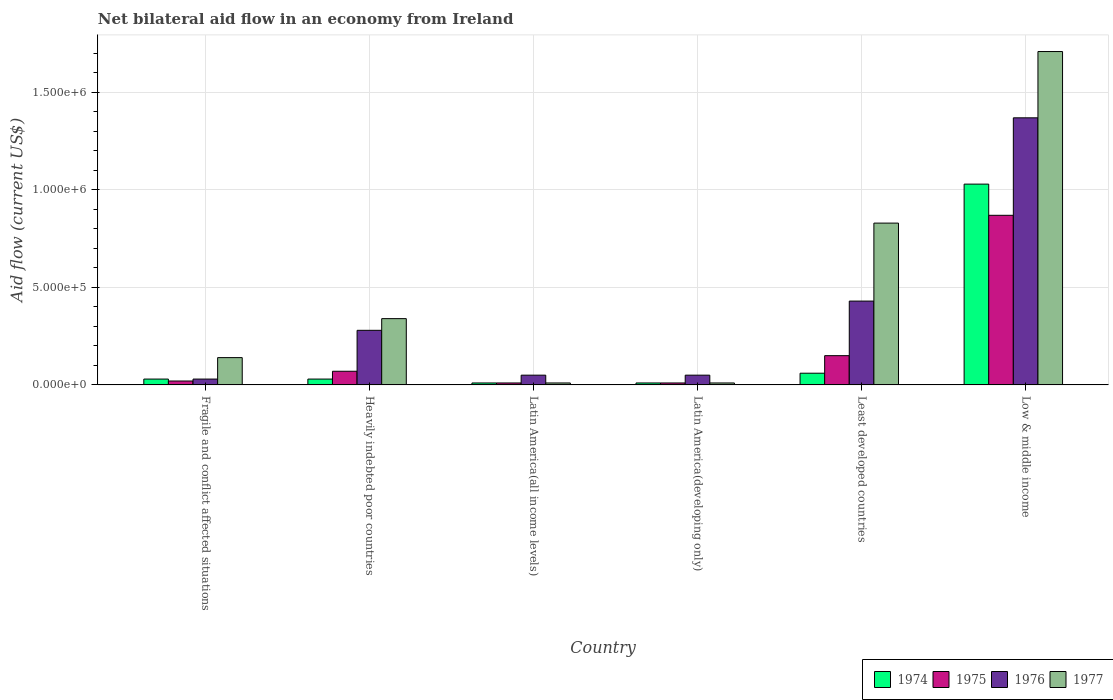How many different coloured bars are there?
Keep it short and to the point. 4. How many groups of bars are there?
Give a very brief answer. 6. Are the number of bars on each tick of the X-axis equal?
Provide a succinct answer. Yes. How many bars are there on the 1st tick from the left?
Make the answer very short. 4. How many bars are there on the 1st tick from the right?
Ensure brevity in your answer.  4. What is the label of the 6th group of bars from the left?
Give a very brief answer. Low & middle income. What is the net bilateral aid flow in 1977 in Latin America(developing only)?
Provide a succinct answer. 10000. Across all countries, what is the maximum net bilateral aid flow in 1977?
Your answer should be compact. 1.71e+06. In which country was the net bilateral aid flow in 1977 maximum?
Your response must be concise. Low & middle income. In which country was the net bilateral aid flow in 1975 minimum?
Offer a terse response. Latin America(all income levels). What is the total net bilateral aid flow in 1974 in the graph?
Offer a terse response. 1.17e+06. What is the difference between the net bilateral aid flow in 1977 in Latin America(all income levels) and that in Low & middle income?
Offer a very short reply. -1.70e+06. What is the difference between the net bilateral aid flow in 1977 in Low & middle income and the net bilateral aid flow in 1974 in Least developed countries?
Provide a succinct answer. 1.65e+06. What is the average net bilateral aid flow in 1976 per country?
Provide a succinct answer. 3.68e+05. What is the ratio of the net bilateral aid flow in 1974 in Latin America(all income levels) to that in Low & middle income?
Provide a succinct answer. 0.01. What is the difference between the highest and the lowest net bilateral aid flow in 1974?
Offer a terse response. 1.02e+06. Is it the case that in every country, the sum of the net bilateral aid flow in 1975 and net bilateral aid flow in 1977 is greater than the sum of net bilateral aid flow in 1976 and net bilateral aid flow in 1974?
Provide a short and direct response. No. What does the 2nd bar from the right in Low & middle income represents?
Provide a succinct answer. 1976. How many bars are there?
Provide a short and direct response. 24. Are all the bars in the graph horizontal?
Your answer should be very brief. No. How many countries are there in the graph?
Provide a succinct answer. 6. What is the difference between two consecutive major ticks on the Y-axis?
Your response must be concise. 5.00e+05. Does the graph contain grids?
Your response must be concise. Yes. How many legend labels are there?
Offer a terse response. 4. What is the title of the graph?
Provide a succinct answer. Net bilateral aid flow in an economy from Ireland. Does "1981" appear as one of the legend labels in the graph?
Ensure brevity in your answer.  No. What is the label or title of the X-axis?
Offer a terse response. Country. What is the label or title of the Y-axis?
Your response must be concise. Aid flow (current US$). What is the Aid flow (current US$) of 1975 in Fragile and conflict affected situations?
Your answer should be compact. 2.00e+04. What is the Aid flow (current US$) of 1977 in Fragile and conflict affected situations?
Ensure brevity in your answer.  1.40e+05. What is the Aid flow (current US$) in 1975 in Heavily indebted poor countries?
Offer a very short reply. 7.00e+04. What is the Aid flow (current US$) of 1976 in Heavily indebted poor countries?
Your answer should be compact. 2.80e+05. What is the Aid flow (current US$) of 1974 in Latin America(all income levels)?
Keep it short and to the point. 10000. What is the Aid flow (current US$) in 1976 in Latin America(all income levels)?
Your answer should be compact. 5.00e+04. What is the Aid flow (current US$) in 1977 in Latin America(all income levels)?
Your answer should be compact. 10000. What is the Aid flow (current US$) of 1974 in Least developed countries?
Your answer should be compact. 6.00e+04. What is the Aid flow (current US$) of 1976 in Least developed countries?
Offer a very short reply. 4.30e+05. What is the Aid flow (current US$) in 1977 in Least developed countries?
Offer a terse response. 8.30e+05. What is the Aid flow (current US$) of 1974 in Low & middle income?
Your answer should be compact. 1.03e+06. What is the Aid flow (current US$) of 1975 in Low & middle income?
Give a very brief answer. 8.70e+05. What is the Aid flow (current US$) of 1976 in Low & middle income?
Make the answer very short. 1.37e+06. What is the Aid flow (current US$) in 1977 in Low & middle income?
Your answer should be very brief. 1.71e+06. Across all countries, what is the maximum Aid flow (current US$) of 1974?
Make the answer very short. 1.03e+06. Across all countries, what is the maximum Aid flow (current US$) of 1975?
Provide a short and direct response. 8.70e+05. Across all countries, what is the maximum Aid flow (current US$) in 1976?
Your response must be concise. 1.37e+06. Across all countries, what is the maximum Aid flow (current US$) in 1977?
Ensure brevity in your answer.  1.71e+06. Across all countries, what is the minimum Aid flow (current US$) of 1974?
Offer a terse response. 10000. What is the total Aid flow (current US$) in 1974 in the graph?
Keep it short and to the point. 1.17e+06. What is the total Aid flow (current US$) of 1975 in the graph?
Offer a terse response. 1.13e+06. What is the total Aid flow (current US$) of 1976 in the graph?
Provide a succinct answer. 2.21e+06. What is the total Aid flow (current US$) in 1977 in the graph?
Offer a very short reply. 3.04e+06. What is the difference between the Aid flow (current US$) of 1977 in Fragile and conflict affected situations and that in Heavily indebted poor countries?
Ensure brevity in your answer.  -2.00e+05. What is the difference between the Aid flow (current US$) in 1974 in Fragile and conflict affected situations and that in Latin America(developing only)?
Make the answer very short. 2.00e+04. What is the difference between the Aid flow (current US$) of 1976 in Fragile and conflict affected situations and that in Latin America(developing only)?
Your answer should be very brief. -2.00e+04. What is the difference between the Aid flow (current US$) in 1977 in Fragile and conflict affected situations and that in Latin America(developing only)?
Your answer should be very brief. 1.30e+05. What is the difference between the Aid flow (current US$) of 1975 in Fragile and conflict affected situations and that in Least developed countries?
Ensure brevity in your answer.  -1.30e+05. What is the difference between the Aid flow (current US$) of 1976 in Fragile and conflict affected situations and that in Least developed countries?
Your answer should be very brief. -4.00e+05. What is the difference between the Aid flow (current US$) of 1977 in Fragile and conflict affected situations and that in Least developed countries?
Make the answer very short. -6.90e+05. What is the difference between the Aid flow (current US$) of 1974 in Fragile and conflict affected situations and that in Low & middle income?
Offer a terse response. -1.00e+06. What is the difference between the Aid flow (current US$) of 1975 in Fragile and conflict affected situations and that in Low & middle income?
Keep it short and to the point. -8.50e+05. What is the difference between the Aid flow (current US$) in 1976 in Fragile and conflict affected situations and that in Low & middle income?
Give a very brief answer. -1.34e+06. What is the difference between the Aid flow (current US$) in 1977 in Fragile and conflict affected situations and that in Low & middle income?
Keep it short and to the point. -1.57e+06. What is the difference between the Aid flow (current US$) in 1974 in Heavily indebted poor countries and that in Latin America(all income levels)?
Ensure brevity in your answer.  2.00e+04. What is the difference between the Aid flow (current US$) of 1977 in Heavily indebted poor countries and that in Latin America(all income levels)?
Provide a short and direct response. 3.30e+05. What is the difference between the Aid flow (current US$) of 1974 in Heavily indebted poor countries and that in Latin America(developing only)?
Keep it short and to the point. 2.00e+04. What is the difference between the Aid flow (current US$) of 1975 in Heavily indebted poor countries and that in Latin America(developing only)?
Keep it short and to the point. 6.00e+04. What is the difference between the Aid flow (current US$) in 1976 in Heavily indebted poor countries and that in Latin America(developing only)?
Make the answer very short. 2.30e+05. What is the difference between the Aid flow (current US$) in 1977 in Heavily indebted poor countries and that in Least developed countries?
Your answer should be compact. -4.90e+05. What is the difference between the Aid flow (current US$) of 1975 in Heavily indebted poor countries and that in Low & middle income?
Offer a very short reply. -8.00e+05. What is the difference between the Aid flow (current US$) in 1976 in Heavily indebted poor countries and that in Low & middle income?
Your answer should be compact. -1.09e+06. What is the difference between the Aid flow (current US$) of 1977 in Heavily indebted poor countries and that in Low & middle income?
Offer a very short reply. -1.37e+06. What is the difference between the Aid flow (current US$) in 1974 in Latin America(all income levels) and that in Latin America(developing only)?
Your answer should be compact. 0. What is the difference between the Aid flow (current US$) of 1976 in Latin America(all income levels) and that in Latin America(developing only)?
Your answer should be compact. 0. What is the difference between the Aid flow (current US$) in 1977 in Latin America(all income levels) and that in Latin America(developing only)?
Provide a short and direct response. 0. What is the difference between the Aid flow (current US$) of 1976 in Latin America(all income levels) and that in Least developed countries?
Offer a terse response. -3.80e+05. What is the difference between the Aid flow (current US$) of 1977 in Latin America(all income levels) and that in Least developed countries?
Your response must be concise. -8.20e+05. What is the difference between the Aid flow (current US$) of 1974 in Latin America(all income levels) and that in Low & middle income?
Provide a short and direct response. -1.02e+06. What is the difference between the Aid flow (current US$) of 1975 in Latin America(all income levels) and that in Low & middle income?
Your answer should be compact. -8.60e+05. What is the difference between the Aid flow (current US$) of 1976 in Latin America(all income levels) and that in Low & middle income?
Make the answer very short. -1.32e+06. What is the difference between the Aid flow (current US$) of 1977 in Latin America(all income levels) and that in Low & middle income?
Keep it short and to the point. -1.70e+06. What is the difference between the Aid flow (current US$) of 1974 in Latin America(developing only) and that in Least developed countries?
Offer a very short reply. -5.00e+04. What is the difference between the Aid flow (current US$) in 1976 in Latin America(developing only) and that in Least developed countries?
Your response must be concise. -3.80e+05. What is the difference between the Aid flow (current US$) of 1977 in Latin America(developing only) and that in Least developed countries?
Offer a very short reply. -8.20e+05. What is the difference between the Aid flow (current US$) in 1974 in Latin America(developing only) and that in Low & middle income?
Provide a succinct answer. -1.02e+06. What is the difference between the Aid flow (current US$) in 1975 in Latin America(developing only) and that in Low & middle income?
Give a very brief answer. -8.60e+05. What is the difference between the Aid flow (current US$) of 1976 in Latin America(developing only) and that in Low & middle income?
Your response must be concise. -1.32e+06. What is the difference between the Aid flow (current US$) of 1977 in Latin America(developing only) and that in Low & middle income?
Offer a very short reply. -1.70e+06. What is the difference between the Aid flow (current US$) of 1974 in Least developed countries and that in Low & middle income?
Offer a very short reply. -9.70e+05. What is the difference between the Aid flow (current US$) in 1975 in Least developed countries and that in Low & middle income?
Ensure brevity in your answer.  -7.20e+05. What is the difference between the Aid flow (current US$) of 1976 in Least developed countries and that in Low & middle income?
Offer a terse response. -9.40e+05. What is the difference between the Aid flow (current US$) in 1977 in Least developed countries and that in Low & middle income?
Your answer should be very brief. -8.80e+05. What is the difference between the Aid flow (current US$) in 1974 in Fragile and conflict affected situations and the Aid flow (current US$) in 1975 in Heavily indebted poor countries?
Your answer should be very brief. -4.00e+04. What is the difference between the Aid flow (current US$) in 1974 in Fragile and conflict affected situations and the Aid flow (current US$) in 1977 in Heavily indebted poor countries?
Keep it short and to the point. -3.10e+05. What is the difference between the Aid flow (current US$) in 1975 in Fragile and conflict affected situations and the Aid flow (current US$) in 1977 in Heavily indebted poor countries?
Your answer should be compact. -3.20e+05. What is the difference between the Aid flow (current US$) of 1976 in Fragile and conflict affected situations and the Aid flow (current US$) of 1977 in Heavily indebted poor countries?
Your answer should be compact. -3.10e+05. What is the difference between the Aid flow (current US$) of 1974 in Fragile and conflict affected situations and the Aid flow (current US$) of 1975 in Latin America(all income levels)?
Make the answer very short. 2.00e+04. What is the difference between the Aid flow (current US$) of 1975 in Fragile and conflict affected situations and the Aid flow (current US$) of 1977 in Latin America(developing only)?
Provide a short and direct response. 10000. What is the difference between the Aid flow (current US$) of 1976 in Fragile and conflict affected situations and the Aid flow (current US$) of 1977 in Latin America(developing only)?
Offer a terse response. 2.00e+04. What is the difference between the Aid flow (current US$) in 1974 in Fragile and conflict affected situations and the Aid flow (current US$) in 1976 in Least developed countries?
Offer a very short reply. -4.00e+05. What is the difference between the Aid flow (current US$) of 1974 in Fragile and conflict affected situations and the Aid flow (current US$) of 1977 in Least developed countries?
Your response must be concise. -8.00e+05. What is the difference between the Aid flow (current US$) of 1975 in Fragile and conflict affected situations and the Aid flow (current US$) of 1976 in Least developed countries?
Provide a succinct answer. -4.10e+05. What is the difference between the Aid flow (current US$) of 1975 in Fragile and conflict affected situations and the Aid flow (current US$) of 1977 in Least developed countries?
Your answer should be compact. -8.10e+05. What is the difference between the Aid flow (current US$) in 1976 in Fragile and conflict affected situations and the Aid flow (current US$) in 1977 in Least developed countries?
Ensure brevity in your answer.  -8.00e+05. What is the difference between the Aid flow (current US$) in 1974 in Fragile and conflict affected situations and the Aid flow (current US$) in 1975 in Low & middle income?
Your response must be concise. -8.40e+05. What is the difference between the Aid flow (current US$) of 1974 in Fragile and conflict affected situations and the Aid flow (current US$) of 1976 in Low & middle income?
Make the answer very short. -1.34e+06. What is the difference between the Aid flow (current US$) in 1974 in Fragile and conflict affected situations and the Aid flow (current US$) in 1977 in Low & middle income?
Offer a very short reply. -1.68e+06. What is the difference between the Aid flow (current US$) of 1975 in Fragile and conflict affected situations and the Aid flow (current US$) of 1976 in Low & middle income?
Ensure brevity in your answer.  -1.35e+06. What is the difference between the Aid flow (current US$) in 1975 in Fragile and conflict affected situations and the Aid flow (current US$) in 1977 in Low & middle income?
Keep it short and to the point. -1.69e+06. What is the difference between the Aid flow (current US$) of 1976 in Fragile and conflict affected situations and the Aid flow (current US$) of 1977 in Low & middle income?
Give a very brief answer. -1.68e+06. What is the difference between the Aid flow (current US$) in 1974 in Heavily indebted poor countries and the Aid flow (current US$) in 1975 in Latin America(all income levels)?
Offer a terse response. 2.00e+04. What is the difference between the Aid flow (current US$) of 1975 in Heavily indebted poor countries and the Aid flow (current US$) of 1976 in Latin America(all income levels)?
Your answer should be compact. 2.00e+04. What is the difference between the Aid flow (current US$) in 1976 in Heavily indebted poor countries and the Aid flow (current US$) in 1977 in Latin America(all income levels)?
Keep it short and to the point. 2.70e+05. What is the difference between the Aid flow (current US$) of 1974 in Heavily indebted poor countries and the Aid flow (current US$) of 1975 in Latin America(developing only)?
Make the answer very short. 2.00e+04. What is the difference between the Aid flow (current US$) of 1974 in Heavily indebted poor countries and the Aid flow (current US$) of 1977 in Latin America(developing only)?
Offer a terse response. 2.00e+04. What is the difference between the Aid flow (current US$) of 1975 in Heavily indebted poor countries and the Aid flow (current US$) of 1976 in Latin America(developing only)?
Provide a short and direct response. 2.00e+04. What is the difference between the Aid flow (current US$) of 1975 in Heavily indebted poor countries and the Aid flow (current US$) of 1977 in Latin America(developing only)?
Offer a terse response. 6.00e+04. What is the difference between the Aid flow (current US$) in 1976 in Heavily indebted poor countries and the Aid flow (current US$) in 1977 in Latin America(developing only)?
Keep it short and to the point. 2.70e+05. What is the difference between the Aid flow (current US$) of 1974 in Heavily indebted poor countries and the Aid flow (current US$) of 1975 in Least developed countries?
Make the answer very short. -1.20e+05. What is the difference between the Aid flow (current US$) in 1974 in Heavily indebted poor countries and the Aid flow (current US$) in 1976 in Least developed countries?
Ensure brevity in your answer.  -4.00e+05. What is the difference between the Aid flow (current US$) in 1974 in Heavily indebted poor countries and the Aid flow (current US$) in 1977 in Least developed countries?
Provide a short and direct response. -8.00e+05. What is the difference between the Aid flow (current US$) in 1975 in Heavily indebted poor countries and the Aid flow (current US$) in 1976 in Least developed countries?
Your answer should be compact. -3.60e+05. What is the difference between the Aid flow (current US$) of 1975 in Heavily indebted poor countries and the Aid flow (current US$) of 1977 in Least developed countries?
Keep it short and to the point. -7.60e+05. What is the difference between the Aid flow (current US$) in 1976 in Heavily indebted poor countries and the Aid flow (current US$) in 1977 in Least developed countries?
Offer a very short reply. -5.50e+05. What is the difference between the Aid flow (current US$) in 1974 in Heavily indebted poor countries and the Aid flow (current US$) in 1975 in Low & middle income?
Give a very brief answer. -8.40e+05. What is the difference between the Aid flow (current US$) of 1974 in Heavily indebted poor countries and the Aid flow (current US$) of 1976 in Low & middle income?
Keep it short and to the point. -1.34e+06. What is the difference between the Aid flow (current US$) of 1974 in Heavily indebted poor countries and the Aid flow (current US$) of 1977 in Low & middle income?
Offer a very short reply. -1.68e+06. What is the difference between the Aid flow (current US$) of 1975 in Heavily indebted poor countries and the Aid flow (current US$) of 1976 in Low & middle income?
Your answer should be very brief. -1.30e+06. What is the difference between the Aid flow (current US$) of 1975 in Heavily indebted poor countries and the Aid flow (current US$) of 1977 in Low & middle income?
Your response must be concise. -1.64e+06. What is the difference between the Aid flow (current US$) in 1976 in Heavily indebted poor countries and the Aid flow (current US$) in 1977 in Low & middle income?
Provide a short and direct response. -1.43e+06. What is the difference between the Aid flow (current US$) in 1974 in Latin America(all income levels) and the Aid flow (current US$) in 1975 in Latin America(developing only)?
Provide a succinct answer. 0. What is the difference between the Aid flow (current US$) in 1975 in Latin America(all income levels) and the Aid flow (current US$) in 1976 in Latin America(developing only)?
Keep it short and to the point. -4.00e+04. What is the difference between the Aid flow (current US$) of 1976 in Latin America(all income levels) and the Aid flow (current US$) of 1977 in Latin America(developing only)?
Keep it short and to the point. 4.00e+04. What is the difference between the Aid flow (current US$) in 1974 in Latin America(all income levels) and the Aid flow (current US$) in 1975 in Least developed countries?
Your answer should be very brief. -1.40e+05. What is the difference between the Aid flow (current US$) in 1974 in Latin America(all income levels) and the Aid flow (current US$) in 1976 in Least developed countries?
Offer a very short reply. -4.20e+05. What is the difference between the Aid flow (current US$) of 1974 in Latin America(all income levels) and the Aid flow (current US$) of 1977 in Least developed countries?
Provide a short and direct response. -8.20e+05. What is the difference between the Aid flow (current US$) in 1975 in Latin America(all income levels) and the Aid flow (current US$) in 1976 in Least developed countries?
Give a very brief answer. -4.20e+05. What is the difference between the Aid flow (current US$) in 1975 in Latin America(all income levels) and the Aid flow (current US$) in 1977 in Least developed countries?
Your answer should be compact. -8.20e+05. What is the difference between the Aid flow (current US$) in 1976 in Latin America(all income levels) and the Aid flow (current US$) in 1977 in Least developed countries?
Your answer should be compact. -7.80e+05. What is the difference between the Aid flow (current US$) in 1974 in Latin America(all income levels) and the Aid flow (current US$) in 1975 in Low & middle income?
Offer a terse response. -8.60e+05. What is the difference between the Aid flow (current US$) in 1974 in Latin America(all income levels) and the Aid flow (current US$) in 1976 in Low & middle income?
Offer a terse response. -1.36e+06. What is the difference between the Aid flow (current US$) of 1974 in Latin America(all income levels) and the Aid flow (current US$) of 1977 in Low & middle income?
Provide a succinct answer. -1.70e+06. What is the difference between the Aid flow (current US$) in 1975 in Latin America(all income levels) and the Aid flow (current US$) in 1976 in Low & middle income?
Your answer should be very brief. -1.36e+06. What is the difference between the Aid flow (current US$) in 1975 in Latin America(all income levels) and the Aid flow (current US$) in 1977 in Low & middle income?
Provide a short and direct response. -1.70e+06. What is the difference between the Aid flow (current US$) of 1976 in Latin America(all income levels) and the Aid flow (current US$) of 1977 in Low & middle income?
Keep it short and to the point. -1.66e+06. What is the difference between the Aid flow (current US$) of 1974 in Latin America(developing only) and the Aid flow (current US$) of 1975 in Least developed countries?
Offer a terse response. -1.40e+05. What is the difference between the Aid flow (current US$) of 1974 in Latin America(developing only) and the Aid flow (current US$) of 1976 in Least developed countries?
Provide a succinct answer. -4.20e+05. What is the difference between the Aid flow (current US$) in 1974 in Latin America(developing only) and the Aid flow (current US$) in 1977 in Least developed countries?
Ensure brevity in your answer.  -8.20e+05. What is the difference between the Aid flow (current US$) in 1975 in Latin America(developing only) and the Aid flow (current US$) in 1976 in Least developed countries?
Your response must be concise. -4.20e+05. What is the difference between the Aid flow (current US$) in 1975 in Latin America(developing only) and the Aid flow (current US$) in 1977 in Least developed countries?
Your answer should be very brief. -8.20e+05. What is the difference between the Aid flow (current US$) in 1976 in Latin America(developing only) and the Aid flow (current US$) in 1977 in Least developed countries?
Your answer should be very brief. -7.80e+05. What is the difference between the Aid flow (current US$) of 1974 in Latin America(developing only) and the Aid flow (current US$) of 1975 in Low & middle income?
Your response must be concise. -8.60e+05. What is the difference between the Aid flow (current US$) of 1974 in Latin America(developing only) and the Aid flow (current US$) of 1976 in Low & middle income?
Make the answer very short. -1.36e+06. What is the difference between the Aid flow (current US$) in 1974 in Latin America(developing only) and the Aid flow (current US$) in 1977 in Low & middle income?
Your answer should be compact. -1.70e+06. What is the difference between the Aid flow (current US$) in 1975 in Latin America(developing only) and the Aid flow (current US$) in 1976 in Low & middle income?
Provide a short and direct response. -1.36e+06. What is the difference between the Aid flow (current US$) in 1975 in Latin America(developing only) and the Aid flow (current US$) in 1977 in Low & middle income?
Make the answer very short. -1.70e+06. What is the difference between the Aid flow (current US$) of 1976 in Latin America(developing only) and the Aid flow (current US$) of 1977 in Low & middle income?
Offer a very short reply. -1.66e+06. What is the difference between the Aid flow (current US$) of 1974 in Least developed countries and the Aid flow (current US$) of 1975 in Low & middle income?
Your answer should be compact. -8.10e+05. What is the difference between the Aid flow (current US$) of 1974 in Least developed countries and the Aid flow (current US$) of 1976 in Low & middle income?
Your answer should be very brief. -1.31e+06. What is the difference between the Aid flow (current US$) of 1974 in Least developed countries and the Aid flow (current US$) of 1977 in Low & middle income?
Make the answer very short. -1.65e+06. What is the difference between the Aid flow (current US$) in 1975 in Least developed countries and the Aid flow (current US$) in 1976 in Low & middle income?
Keep it short and to the point. -1.22e+06. What is the difference between the Aid flow (current US$) of 1975 in Least developed countries and the Aid flow (current US$) of 1977 in Low & middle income?
Your response must be concise. -1.56e+06. What is the difference between the Aid flow (current US$) of 1976 in Least developed countries and the Aid flow (current US$) of 1977 in Low & middle income?
Offer a terse response. -1.28e+06. What is the average Aid flow (current US$) of 1974 per country?
Provide a short and direct response. 1.95e+05. What is the average Aid flow (current US$) of 1975 per country?
Provide a short and direct response. 1.88e+05. What is the average Aid flow (current US$) of 1976 per country?
Your answer should be compact. 3.68e+05. What is the average Aid flow (current US$) of 1977 per country?
Your response must be concise. 5.07e+05. What is the difference between the Aid flow (current US$) in 1974 and Aid flow (current US$) in 1975 in Fragile and conflict affected situations?
Your answer should be compact. 10000. What is the difference between the Aid flow (current US$) in 1974 and Aid flow (current US$) in 1977 in Fragile and conflict affected situations?
Keep it short and to the point. -1.10e+05. What is the difference between the Aid flow (current US$) of 1975 and Aid flow (current US$) of 1976 in Fragile and conflict affected situations?
Keep it short and to the point. -10000. What is the difference between the Aid flow (current US$) in 1974 and Aid flow (current US$) in 1976 in Heavily indebted poor countries?
Offer a terse response. -2.50e+05. What is the difference between the Aid flow (current US$) of 1974 and Aid flow (current US$) of 1977 in Heavily indebted poor countries?
Ensure brevity in your answer.  -3.10e+05. What is the difference between the Aid flow (current US$) in 1975 and Aid flow (current US$) in 1976 in Heavily indebted poor countries?
Make the answer very short. -2.10e+05. What is the difference between the Aid flow (current US$) in 1975 and Aid flow (current US$) in 1977 in Heavily indebted poor countries?
Your response must be concise. -2.70e+05. What is the difference between the Aid flow (current US$) of 1974 and Aid flow (current US$) of 1975 in Latin America(all income levels)?
Make the answer very short. 0. What is the difference between the Aid flow (current US$) of 1975 and Aid flow (current US$) of 1977 in Latin America(all income levels)?
Offer a very short reply. 0. What is the difference between the Aid flow (current US$) in 1976 and Aid flow (current US$) in 1977 in Latin America(all income levels)?
Your answer should be compact. 4.00e+04. What is the difference between the Aid flow (current US$) in 1974 and Aid flow (current US$) in 1975 in Latin America(developing only)?
Offer a very short reply. 0. What is the difference between the Aid flow (current US$) of 1974 and Aid flow (current US$) of 1977 in Latin America(developing only)?
Ensure brevity in your answer.  0. What is the difference between the Aid flow (current US$) in 1974 and Aid flow (current US$) in 1976 in Least developed countries?
Ensure brevity in your answer.  -3.70e+05. What is the difference between the Aid flow (current US$) of 1974 and Aid flow (current US$) of 1977 in Least developed countries?
Your answer should be compact. -7.70e+05. What is the difference between the Aid flow (current US$) of 1975 and Aid flow (current US$) of 1976 in Least developed countries?
Provide a short and direct response. -2.80e+05. What is the difference between the Aid flow (current US$) of 1975 and Aid flow (current US$) of 1977 in Least developed countries?
Provide a succinct answer. -6.80e+05. What is the difference between the Aid flow (current US$) of 1976 and Aid flow (current US$) of 1977 in Least developed countries?
Keep it short and to the point. -4.00e+05. What is the difference between the Aid flow (current US$) of 1974 and Aid flow (current US$) of 1976 in Low & middle income?
Keep it short and to the point. -3.40e+05. What is the difference between the Aid flow (current US$) in 1974 and Aid flow (current US$) in 1977 in Low & middle income?
Offer a terse response. -6.80e+05. What is the difference between the Aid flow (current US$) in 1975 and Aid flow (current US$) in 1976 in Low & middle income?
Keep it short and to the point. -5.00e+05. What is the difference between the Aid flow (current US$) of 1975 and Aid flow (current US$) of 1977 in Low & middle income?
Offer a very short reply. -8.40e+05. What is the difference between the Aid flow (current US$) of 1976 and Aid flow (current US$) of 1977 in Low & middle income?
Offer a very short reply. -3.40e+05. What is the ratio of the Aid flow (current US$) of 1974 in Fragile and conflict affected situations to that in Heavily indebted poor countries?
Offer a very short reply. 1. What is the ratio of the Aid flow (current US$) of 1975 in Fragile and conflict affected situations to that in Heavily indebted poor countries?
Your response must be concise. 0.29. What is the ratio of the Aid flow (current US$) in 1976 in Fragile and conflict affected situations to that in Heavily indebted poor countries?
Give a very brief answer. 0.11. What is the ratio of the Aid flow (current US$) in 1977 in Fragile and conflict affected situations to that in Heavily indebted poor countries?
Give a very brief answer. 0.41. What is the ratio of the Aid flow (current US$) in 1974 in Fragile and conflict affected situations to that in Latin America(all income levels)?
Offer a very short reply. 3. What is the ratio of the Aid flow (current US$) of 1977 in Fragile and conflict affected situations to that in Latin America(all income levels)?
Your answer should be compact. 14. What is the ratio of the Aid flow (current US$) of 1977 in Fragile and conflict affected situations to that in Latin America(developing only)?
Keep it short and to the point. 14. What is the ratio of the Aid flow (current US$) in 1974 in Fragile and conflict affected situations to that in Least developed countries?
Your answer should be compact. 0.5. What is the ratio of the Aid flow (current US$) of 1975 in Fragile and conflict affected situations to that in Least developed countries?
Your answer should be compact. 0.13. What is the ratio of the Aid flow (current US$) of 1976 in Fragile and conflict affected situations to that in Least developed countries?
Offer a very short reply. 0.07. What is the ratio of the Aid flow (current US$) in 1977 in Fragile and conflict affected situations to that in Least developed countries?
Make the answer very short. 0.17. What is the ratio of the Aid flow (current US$) in 1974 in Fragile and conflict affected situations to that in Low & middle income?
Provide a succinct answer. 0.03. What is the ratio of the Aid flow (current US$) in 1975 in Fragile and conflict affected situations to that in Low & middle income?
Provide a succinct answer. 0.02. What is the ratio of the Aid flow (current US$) in 1976 in Fragile and conflict affected situations to that in Low & middle income?
Give a very brief answer. 0.02. What is the ratio of the Aid flow (current US$) in 1977 in Fragile and conflict affected situations to that in Low & middle income?
Your answer should be compact. 0.08. What is the ratio of the Aid flow (current US$) of 1976 in Heavily indebted poor countries to that in Latin America(all income levels)?
Provide a short and direct response. 5.6. What is the ratio of the Aid flow (current US$) in 1974 in Heavily indebted poor countries to that in Least developed countries?
Provide a short and direct response. 0.5. What is the ratio of the Aid flow (current US$) of 1975 in Heavily indebted poor countries to that in Least developed countries?
Offer a terse response. 0.47. What is the ratio of the Aid flow (current US$) in 1976 in Heavily indebted poor countries to that in Least developed countries?
Your answer should be compact. 0.65. What is the ratio of the Aid flow (current US$) in 1977 in Heavily indebted poor countries to that in Least developed countries?
Offer a terse response. 0.41. What is the ratio of the Aid flow (current US$) in 1974 in Heavily indebted poor countries to that in Low & middle income?
Provide a short and direct response. 0.03. What is the ratio of the Aid flow (current US$) in 1975 in Heavily indebted poor countries to that in Low & middle income?
Your answer should be compact. 0.08. What is the ratio of the Aid flow (current US$) in 1976 in Heavily indebted poor countries to that in Low & middle income?
Your answer should be compact. 0.2. What is the ratio of the Aid flow (current US$) in 1977 in Heavily indebted poor countries to that in Low & middle income?
Your response must be concise. 0.2. What is the ratio of the Aid flow (current US$) in 1974 in Latin America(all income levels) to that in Latin America(developing only)?
Give a very brief answer. 1. What is the ratio of the Aid flow (current US$) of 1975 in Latin America(all income levels) to that in Latin America(developing only)?
Provide a succinct answer. 1. What is the ratio of the Aid flow (current US$) of 1976 in Latin America(all income levels) to that in Latin America(developing only)?
Keep it short and to the point. 1. What is the ratio of the Aid flow (current US$) of 1977 in Latin America(all income levels) to that in Latin America(developing only)?
Your answer should be compact. 1. What is the ratio of the Aid flow (current US$) of 1974 in Latin America(all income levels) to that in Least developed countries?
Give a very brief answer. 0.17. What is the ratio of the Aid flow (current US$) in 1975 in Latin America(all income levels) to that in Least developed countries?
Your answer should be compact. 0.07. What is the ratio of the Aid flow (current US$) of 1976 in Latin America(all income levels) to that in Least developed countries?
Ensure brevity in your answer.  0.12. What is the ratio of the Aid flow (current US$) in 1977 in Latin America(all income levels) to that in Least developed countries?
Your answer should be compact. 0.01. What is the ratio of the Aid flow (current US$) of 1974 in Latin America(all income levels) to that in Low & middle income?
Keep it short and to the point. 0.01. What is the ratio of the Aid flow (current US$) of 1975 in Latin America(all income levels) to that in Low & middle income?
Provide a succinct answer. 0.01. What is the ratio of the Aid flow (current US$) in 1976 in Latin America(all income levels) to that in Low & middle income?
Offer a very short reply. 0.04. What is the ratio of the Aid flow (current US$) in 1977 in Latin America(all income levels) to that in Low & middle income?
Make the answer very short. 0.01. What is the ratio of the Aid flow (current US$) in 1974 in Latin America(developing only) to that in Least developed countries?
Offer a very short reply. 0.17. What is the ratio of the Aid flow (current US$) of 1975 in Latin America(developing only) to that in Least developed countries?
Your answer should be compact. 0.07. What is the ratio of the Aid flow (current US$) of 1976 in Latin America(developing only) to that in Least developed countries?
Your answer should be very brief. 0.12. What is the ratio of the Aid flow (current US$) of 1977 in Latin America(developing only) to that in Least developed countries?
Your answer should be very brief. 0.01. What is the ratio of the Aid flow (current US$) of 1974 in Latin America(developing only) to that in Low & middle income?
Provide a short and direct response. 0.01. What is the ratio of the Aid flow (current US$) of 1975 in Latin America(developing only) to that in Low & middle income?
Make the answer very short. 0.01. What is the ratio of the Aid flow (current US$) in 1976 in Latin America(developing only) to that in Low & middle income?
Keep it short and to the point. 0.04. What is the ratio of the Aid flow (current US$) of 1977 in Latin America(developing only) to that in Low & middle income?
Give a very brief answer. 0.01. What is the ratio of the Aid flow (current US$) of 1974 in Least developed countries to that in Low & middle income?
Give a very brief answer. 0.06. What is the ratio of the Aid flow (current US$) of 1975 in Least developed countries to that in Low & middle income?
Provide a short and direct response. 0.17. What is the ratio of the Aid flow (current US$) in 1976 in Least developed countries to that in Low & middle income?
Your response must be concise. 0.31. What is the ratio of the Aid flow (current US$) of 1977 in Least developed countries to that in Low & middle income?
Offer a terse response. 0.49. What is the difference between the highest and the second highest Aid flow (current US$) in 1974?
Make the answer very short. 9.70e+05. What is the difference between the highest and the second highest Aid flow (current US$) of 1975?
Provide a short and direct response. 7.20e+05. What is the difference between the highest and the second highest Aid flow (current US$) in 1976?
Your answer should be very brief. 9.40e+05. What is the difference between the highest and the second highest Aid flow (current US$) of 1977?
Offer a very short reply. 8.80e+05. What is the difference between the highest and the lowest Aid flow (current US$) in 1974?
Your answer should be very brief. 1.02e+06. What is the difference between the highest and the lowest Aid flow (current US$) of 1975?
Your answer should be compact. 8.60e+05. What is the difference between the highest and the lowest Aid flow (current US$) of 1976?
Offer a very short reply. 1.34e+06. What is the difference between the highest and the lowest Aid flow (current US$) in 1977?
Keep it short and to the point. 1.70e+06. 